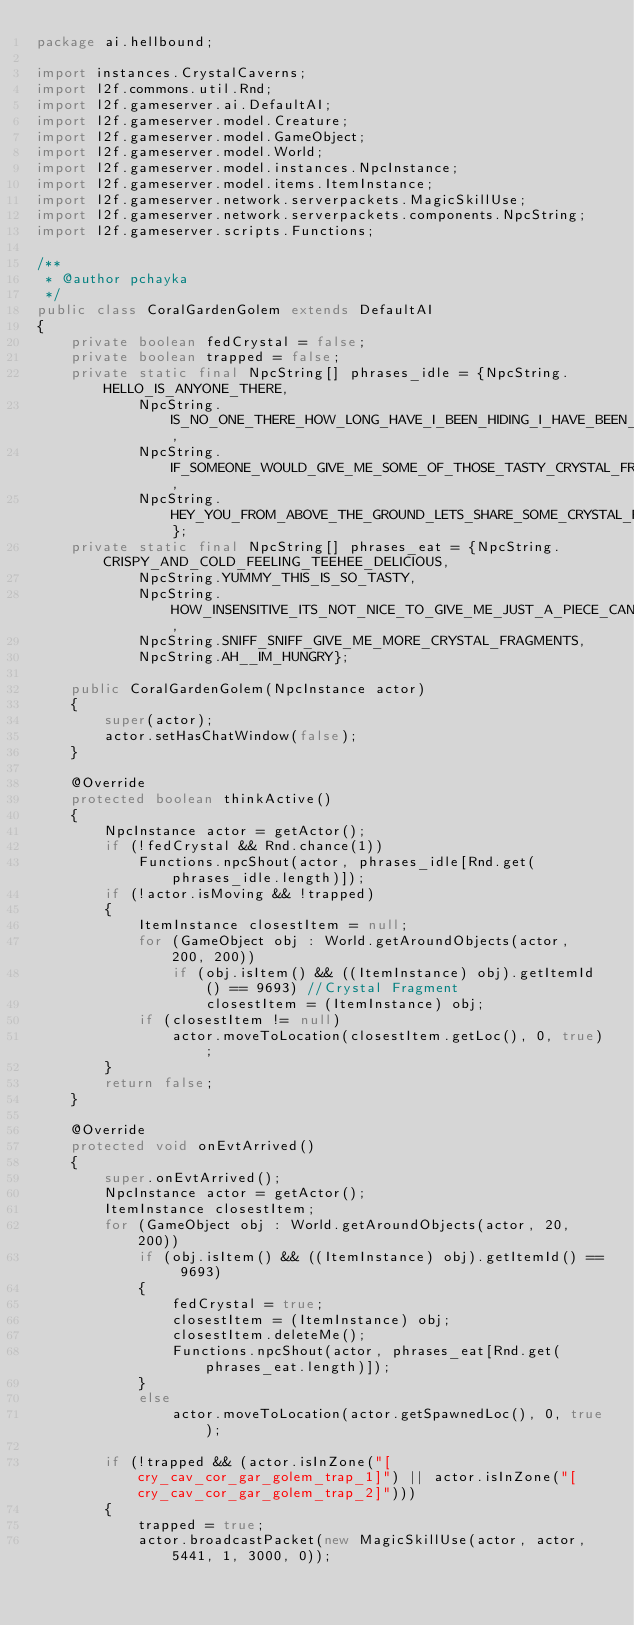<code> <loc_0><loc_0><loc_500><loc_500><_Java_>package ai.hellbound;

import instances.CrystalCaverns;
import l2f.commons.util.Rnd;
import l2f.gameserver.ai.DefaultAI;
import l2f.gameserver.model.Creature;
import l2f.gameserver.model.GameObject;
import l2f.gameserver.model.World;
import l2f.gameserver.model.instances.NpcInstance;
import l2f.gameserver.model.items.ItemInstance;
import l2f.gameserver.network.serverpackets.MagicSkillUse;
import l2f.gameserver.network.serverpackets.components.NpcString;
import l2f.gameserver.scripts.Functions;

/**
 * @author pchayka
 */
public class CoralGardenGolem extends DefaultAI
{
	private boolean fedCrystal = false;
	private boolean trapped = false;
	private static final NpcString[] phrases_idle = {NpcString.HELLO_IS_ANYONE_THERE,
			NpcString.IS_NO_ONE_THERE_HOW_LONG_HAVE_I_BEEN_HIDING_I_HAVE_BEEN_STARVING_FOR_DAYS_AND_CANNOT_HOLD_OUT_ANYMORE,
			NpcString.IF_SOMEONE_WOULD_GIVE_ME_SOME_OF_THOSE_TASTY_CRYSTAL_FRAGMENTS_I_WOULD_GLADLY_TELL_THEM_WHERE_TEARS_IS_HIDING_YUMMY_YUMMY,
			NpcString.HEY_YOU_FROM_ABOVE_THE_GROUND_LETS_SHARE_SOME_CRYSTAL_FRAGMENTS_IF_YOU_HAVE_ANY};
	private static final NpcString[] phrases_eat = {NpcString.CRISPY_AND_COLD_FEELING_TEEHEE_DELICIOUS,
			NpcString.YUMMY_THIS_IS_SO_TASTY,
			NpcString.HOW_INSENSITIVE_ITS_NOT_NICE_TO_GIVE_ME_JUST_A_PIECE_CANT_YOU_GIVE_ME_MORE,
			NpcString.SNIFF_SNIFF_GIVE_ME_MORE_CRYSTAL_FRAGMENTS,
			NpcString.AH__IM_HUNGRY};

	public CoralGardenGolem(NpcInstance actor)
	{
		super(actor);
		actor.setHasChatWindow(false);
	}

	@Override
	protected boolean thinkActive()
	{
		NpcInstance actor = getActor();
		if (!fedCrystal && Rnd.chance(1))
			Functions.npcShout(actor, phrases_idle[Rnd.get(phrases_idle.length)]);
		if (!actor.isMoving && !trapped)
		{
			ItemInstance closestItem = null;
			for (GameObject obj : World.getAroundObjects(actor, 200, 200))
				if (obj.isItem() && ((ItemInstance) obj).getItemId() == 9693) //Crystal Fragment
					closestItem = (ItemInstance) obj;
			if (closestItem != null)
				actor.moveToLocation(closestItem.getLoc(), 0, true);
		}
		return false;
	}

	@Override
	protected void onEvtArrived()
	{
		super.onEvtArrived();
		NpcInstance actor = getActor();
		ItemInstance closestItem;
		for (GameObject obj : World.getAroundObjects(actor, 20, 200))
			if (obj.isItem() && ((ItemInstance) obj).getItemId() == 9693)
			{
				fedCrystal = true;
				closestItem = (ItemInstance) obj;
				closestItem.deleteMe();
				Functions.npcShout(actor, phrases_eat[Rnd.get(phrases_eat.length)]);
			}
			else
				actor.moveToLocation(actor.getSpawnedLoc(), 0, true);

		if (!trapped && (actor.isInZone("[cry_cav_cor_gar_golem_trap_1]") || actor.isInZone("[cry_cav_cor_gar_golem_trap_2]")))
		{
			trapped = true;
			actor.broadcastPacket(new MagicSkillUse(actor, actor, 5441, 1, 3000, 0));</code> 